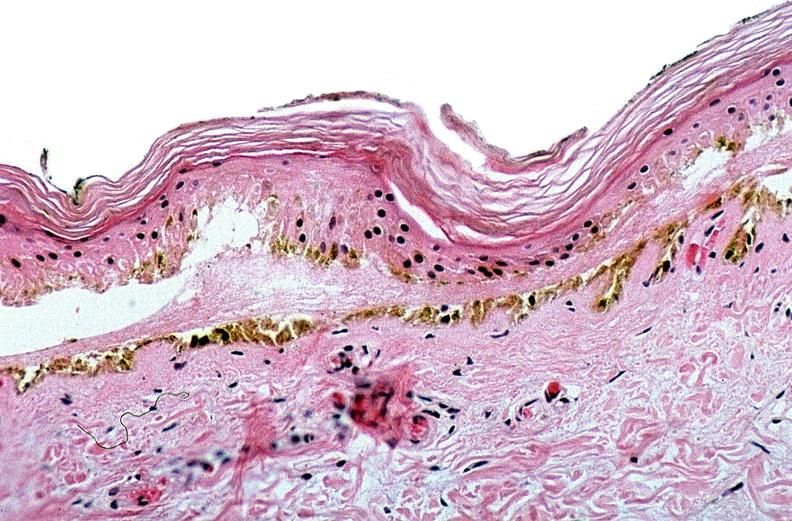what does this image show?
Answer the question using a single word or phrase. Thermal burned skin 